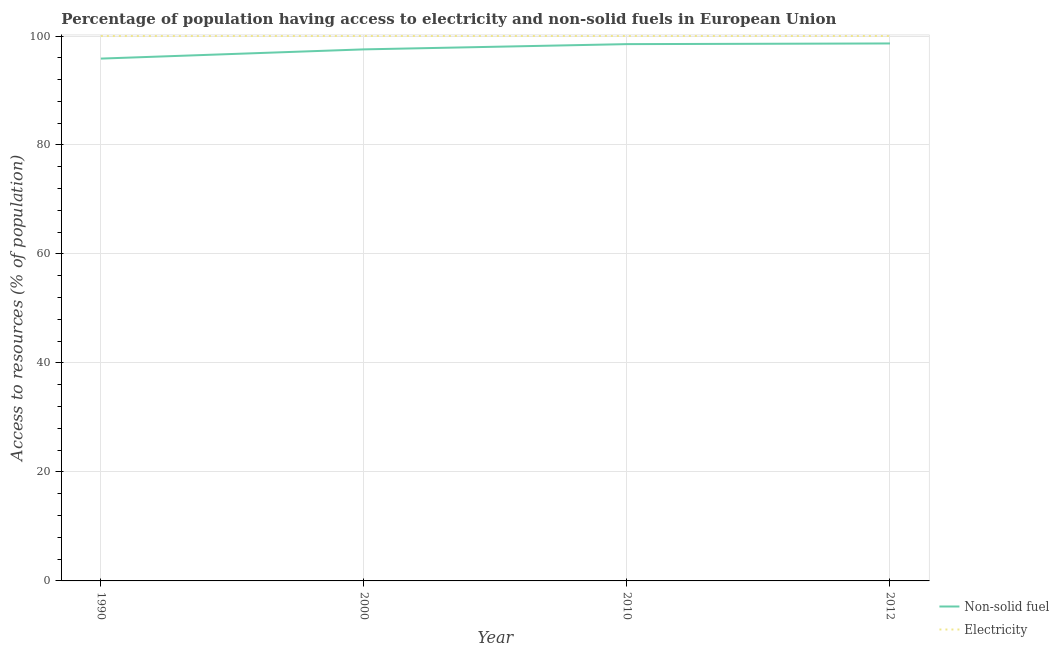Does the line corresponding to percentage of population having access to electricity intersect with the line corresponding to percentage of population having access to non-solid fuel?
Your answer should be very brief. No. Is the number of lines equal to the number of legend labels?
Make the answer very short. Yes. What is the percentage of population having access to non-solid fuel in 2012?
Offer a very short reply. 98.63. Across all years, what is the maximum percentage of population having access to non-solid fuel?
Keep it short and to the point. 98.63. Across all years, what is the minimum percentage of population having access to non-solid fuel?
Provide a succinct answer. 95.85. What is the total percentage of population having access to non-solid fuel in the graph?
Ensure brevity in your answer.  390.54. What is the difference between the percentage of population having access to non-solid fuel in 2000 and that in 2010?
Offer a terse response. -0.96. What is the difference between the percentage of population having access to non-solid fuel in 2000 and the percentage of population having access to electricity in 2012?
Provide a short and direct response. -2.45. What is the average percentage of population having access to non-solid fuel per year?
Offer a very short reply. 97.64. In the year 2012, what is the difference between the percentage of population having access to electricity and percentage of population having access to non-solid fuel?
Your answer should be very brief. 1.37. What is the ratio of the percentage of population having access to electricity in 1990 to that in 2010?
Make the answer very short. 1. Is the percentage of population having access to electricity in 1990 less than that in 2000?
Ensure brevity in your answer.  Yes. What is the difference between the highest and the lowest percentage of population having access to electricity?
Offer a terse response. 0.01. In how many years, is the percentage of population having access to electricity greater than the average percentage of population having access to electricity taken over all years?
Provide a succinct answer. 3. Is the percentage of population having access to electricity strictly less than the percentage of population having access to non-solid fuel over the years?
Keep it short and to the point. No. How many lines are there?
Make the answer very short. 2. How many years are there in the graph?
Keep it short and to the point. 4. What is the difference between two consecutive major ticks on the Y-axis?
Offer a terse response. 20. How are the legend labels stacked?
Ensure brevity in your answer.  Vertical. What is the title of the graph?
Give a very brief answer. Percentage of population having access to electricity and non-solid fuels in European Union. What is the label or title of the Y-axis?
Offer a terse response. Access to resources (% of population). What is the Access to resources (% of population) of Non-solid fuel in 1990?
Provide a short and direct response. 95.85. What is the Access to resources (% of population) of Electricity in 1990?
Offer a very short reply. 99.99. What is the Access to resources (% of population) in Non-solid fuel in 2000?
Offer a terse response. 97.55. What is the Access to resources (% of population) in Non-solid fuel in 2010?
Offer a very short reply. 98.51. What is the Access to resources (% of population) of Non-solid fuel in 2012?
Keep it short and to the point. 98.63. Across all years, what is the maximum Access to resources (% of population) of Non-solid fuel?
Provide a short and direct response. 98.63. Across all years, what is the minimum Access to resources (% of population) of Non-solid fuel?
Provide a short and direct response. 95.85. Across all years, what is the minimum Access to resources (% of population) in Electricity?
Provide a succinct answer. 99.99. What is the total Access to resources (% of population) of Non-solid fuel in the graph?
Provide a short and direct response. 390.54. What is the total Access to resources (% of population) of Electricity in the graph?
Provide a succinct answer. 399.99. What is the difference between the Access to resources (% of population) of Non-solid fuel in 1990 and that in 2000?
Provide a succinct answer. -1.69. What is the difference between the Access to resources (% of population) in Electricity in 1990 and that in 2000?
Your answer should be very brief. -0.01. What is the difference between the Access to resources (% of population) in Non-solid fuel in 1990 and that in 2010?
Offer a terse response. -2.66. What is the difference between the Access to resources (% of population) of Electricity in 1990 and that in 2010?
Give a very brief answer. -0.01. What is the difference between the Access to resources (% of population) of Non-solid fuel in 1990 and that in 2012?
Your answer should be very brief. -2.78. What is the difference between the Access to resources (% of population) of Electricity in 1990 and that in 2012?
Offer a terse response. -0.01. What is the difference between the Access to resources (% of population) of Non-solid fuel in 2000 and that in 2010?
Provide a succinct answer. -0.96. What is the difference between the Access to resources (% of population) of Electricity in 2000 and that in 2010?
Your response must be concise. 0. What is the difference between the Access to resources (% of population) in Non-solid fuel in 2000 and that in 2012?
Provide a short and direct response. -1.09. What is the difference between the Access to resources (% of population) in Non-solid fuel in 2010 and that in 2012?
Your answer should be very brief. -0.12. What is the difference between the Access to resources (% of population) of Electricity in 2010 and that in 2012?
Offer a terse response. 0. What is the difference between the Access to resources (% of population) in Non-solid fuel in 1990 and the Access to resources (% of population) in Electricity in 2000?
Provide a succinct answer. -4.15. What is the difference between the Access to resources (% of population) of Non-solid fuel in 1990 and the Access to resources (% of population) of Electricity in 2010?
Give a very brief answer. -4.15. What is the difference between the Access to resources (% of population) of Non-solid fuel in 1990 and the Access to resources (% of population) of Electricity in 2012?
Your answer should be very brief. -4.15. What is the difference between the Access to resources (% of population) of Non-solid fuel in 2000 and the Access to resources (% of population) of Electricity in 2010?
Make the answer very short. -2.45. What is the difference between the Access to resources (% of population) in Non-solid fuel in 2000 and the Access to resources (% of population) in Electricity in 2012?
Offer a terse response. -2.45. What is the difference between the Access to resources (% of population) of Non-solid fuel in 2010 and the Access to resources (% of population) of Electricity in 2012?
Your response must be concise. -1.49. What is the average Access to resources (% of population) in Non-solid fuel per year?
Offer a terse response. 97.64. What is the average Access to resources (% of population) in Electricity per year?
Offer a very short reply. 100. In the year 1990, what is the difference between the Access to resources (% of population) of Non-solid fuel and Access to resources (% of population) of Electricity?
Offer a terse response. -4.14. In the year 2000, what is the difference between the Access to resources (% of population) in Non-solid fuel and Access to resources (% of population) in Electricity?
Make the answer very short. -2.45. In the year 2010, what is the difference between the Access to resources (% of population) of Non-solid fuel and Access to resources (% of population) of Electricity?
Provide a short and direct response. -1.49. In the year 2012, what is the difference between the Access to resources (% of population) in Non-solid fuel and Access to resources (% of population) in Electricity?
Provide a short and direct response. -1.37. What is the ratio of the Access to resources (% of population) in Non-solid fuel in 1990 to that in 2000?
Your answer should be very brief. 0.98. What is the ratio of the Access to resources (% of population) in Non-solid fuel in 1990 to that in 2010?
Keep it short and to the point. 0.97. What is the ratio of the Access to resources (% of population) in Non-solid fuel in 1990 to that in 2012?
Provide a succinct answer. 0.97. What is the ratio of the Access to resources (% of population) in Electricity in 1990 to that in 2012?
Keep it short and to the point. 1. What is the ratio of the Access to resources (% of population) of Non-solid fuel in 2000 to that in 2010?
Offer a terse response. 0.99. What is the ratio of the Access to resources (% of population) of Electricity in 2000 to that in 2010?
Make the answer very short. 1. What is the ratio of the Access to resources (% of population) of Non-solid fuel in 2000 to that in 2012?
Your answer should be very brief. 0.99. What is the ratio of the Access to resources (% of population) in Electricity in 2010 to that in 2012?
Give a very brief answer. 1. What is the difference between the highest and the second highest Access to resources (% of population) in Non-solid fuel?
Ensure brevity in your answer.  0.12. What is the difference between the highest and the lowest Access to resources (% of population) in Non-solid fuel?
Ensure brevity in your answer.  2.78. What is the difference between the highest and the lowest Access to resources (% of population) of Electricity?
Your response must be concise. 0.01. 